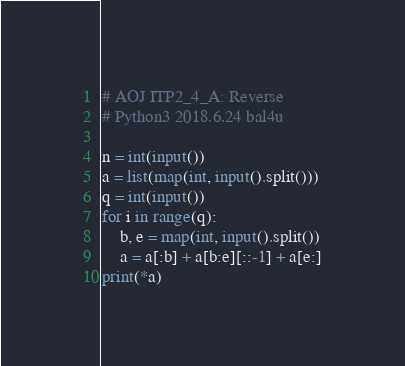Convert code to text. <code><loc_0><loc_0><loc_500><loc_500><_Python_># AOJ ITP2_4_A: Reverse
# Python3 2018.6.24 bal4u

n = int(input())
a = list(map(int, input().split()))
q = int(input())
for i in range(q):
	b, e = map(int, input().split())
	a = a[:b] + a[b:e][::-1] + a[e:]
print(*a)
</code> 